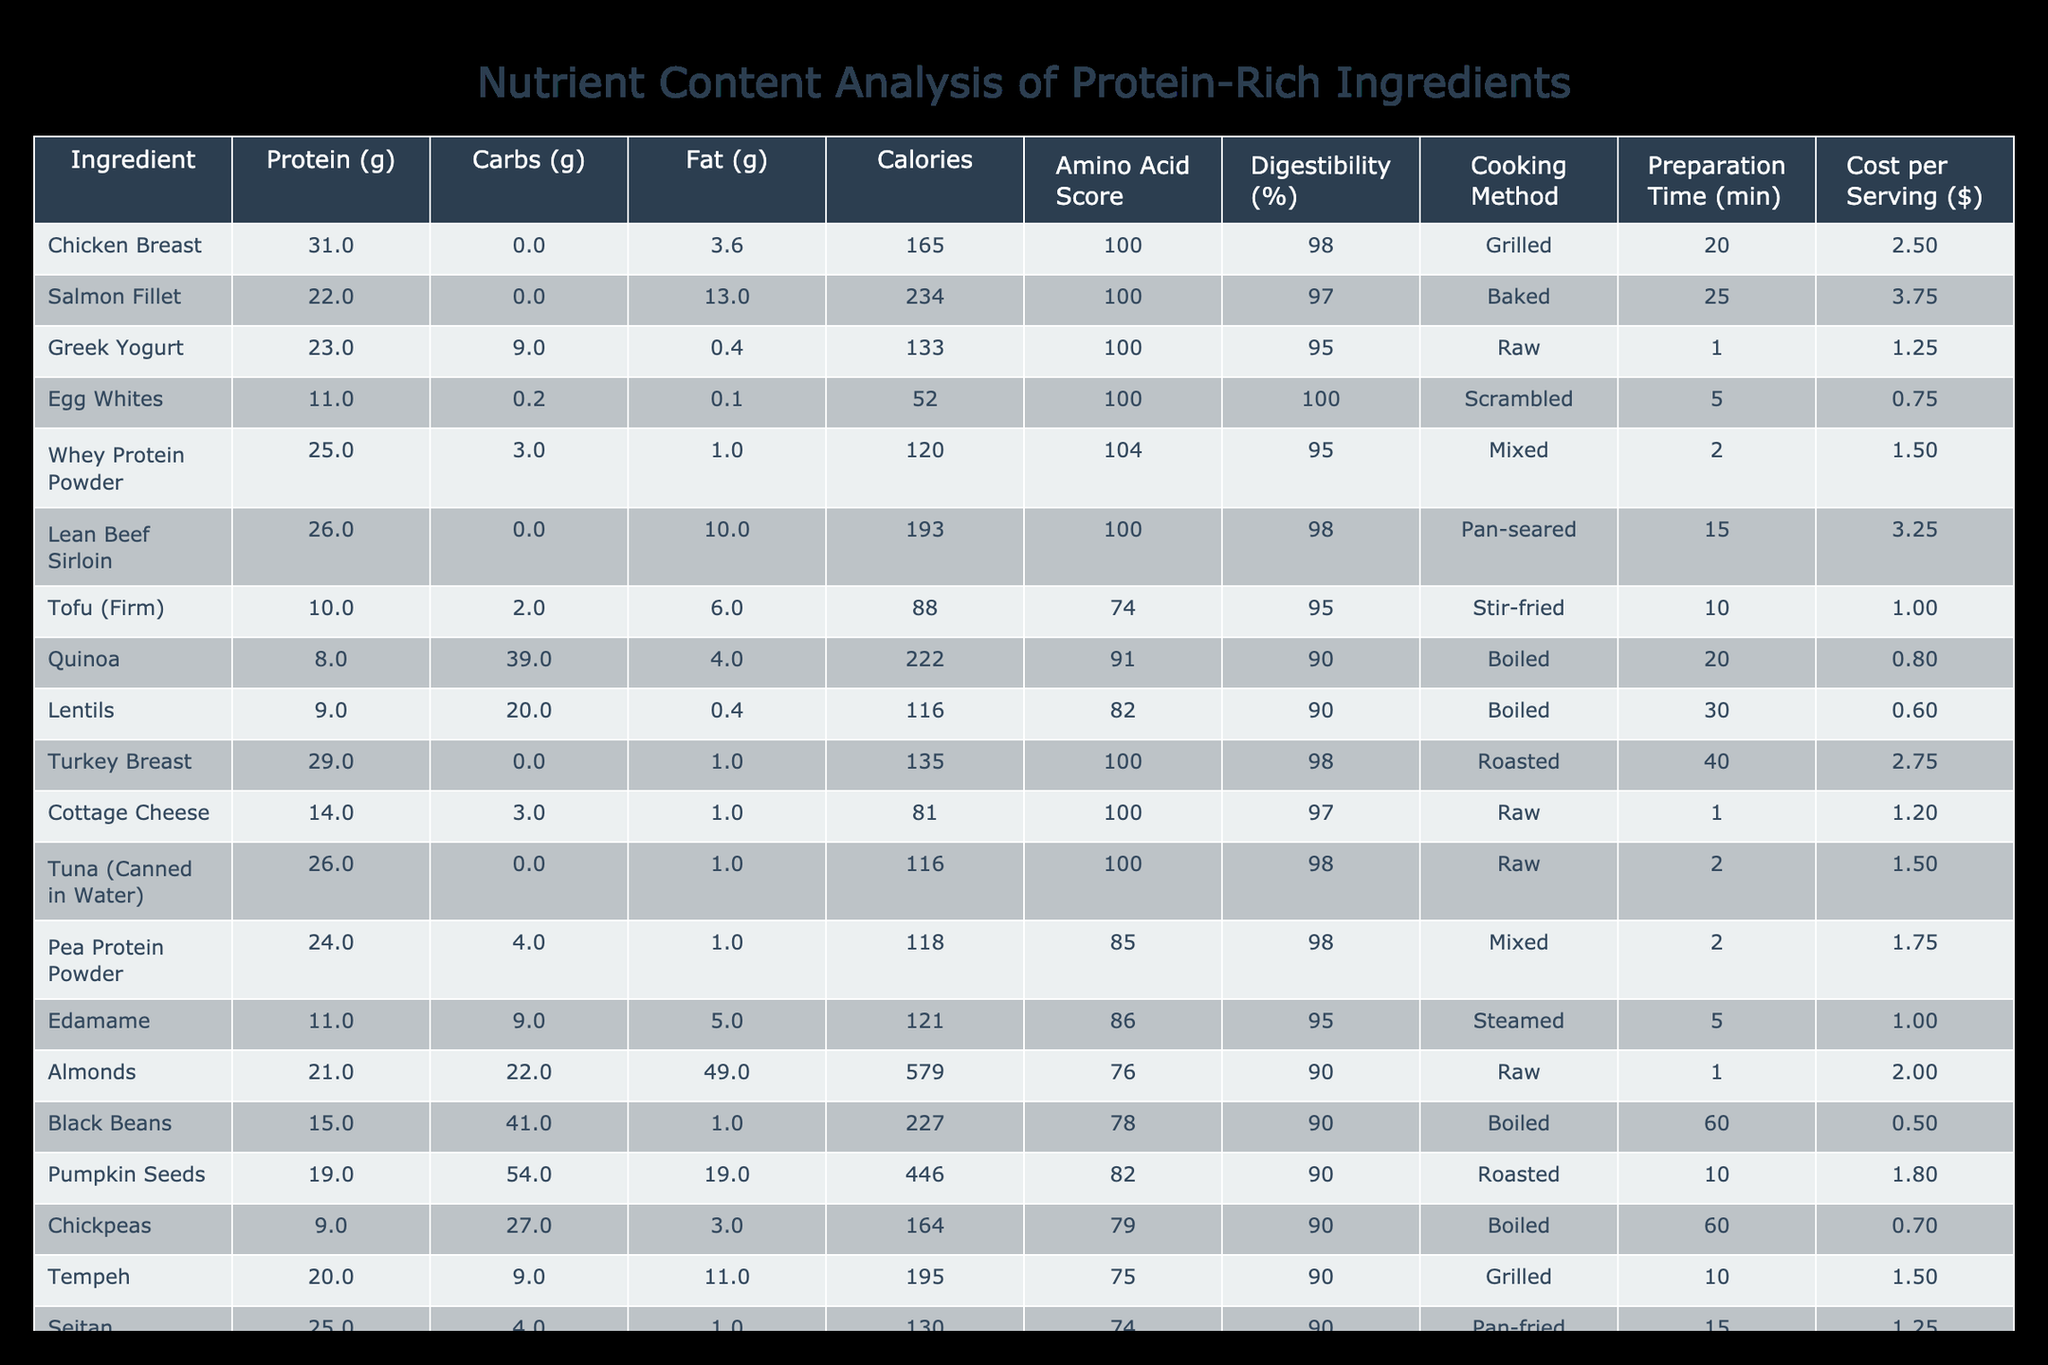What ingredient has the highest protein content? By examining the "Protein (g)" column, Chicken Breast shows the highest value at 31 grams per serving.
Answer: Chicken Breast What is the cost per serving of Salmon Fillet? From the "Cost per Serving ($)" column, Salmon Fillet has a value of 3.75 dollars per serving.
Answer: 3.75 Which ingredient has the lowest digestibility percentage? By looking through the "Digestibility (%)" column, Tofu (Firm) has the lowest value at 95%.
Answer: 95% How much protein do Egg Whites and Chickpeas provide together? Summing the protein from Egg Whites (11g) and Chickpeas (9g) gives us a total of 20 grams (11 + 9 = 20).
Answer: 20 Is the Amino Acid Score of Whey Protein Powder higher than 90? The Amino Acid Score for Whey Protein Powder is 104, which is indeed higher than 90.
Answer: Yes What is the average caloric content of the ingredients listed? The caloric values are: 165, 234, 133, 52, 120, 193, 88, 222, 116, 135, 81, 116, 118, 121, 579, 227, 446, 164, 195, and 130. Summing these gives 2,761 calories; dividing by the number of ingredients (20) results in an average of 138.05, which can be rounded to 138.
Answer: 138 Which cooking method is used for Tuna (Canned in Water)? Referring to the "Cooking Method" column, Tuna (Canned in Water) is listed as "Raw."
Answer: Raw Are all ingredients listed above 70% in their Digestibility? The digestibility percentages reflect that all ingredients, except for Tofu (Firm) and Tempeh which are lower, are above 70%. Therefore, not all ingredients meet this criterion.
Answer: No What is the difference in fat content between Almonds and Chicken Breast? Almonds have 49 grams of fat, while Chicken Breast has 3.6 grams. The difference is calculated as 49 - 3.6 = 45.4 grams.
Answer: 45.4 